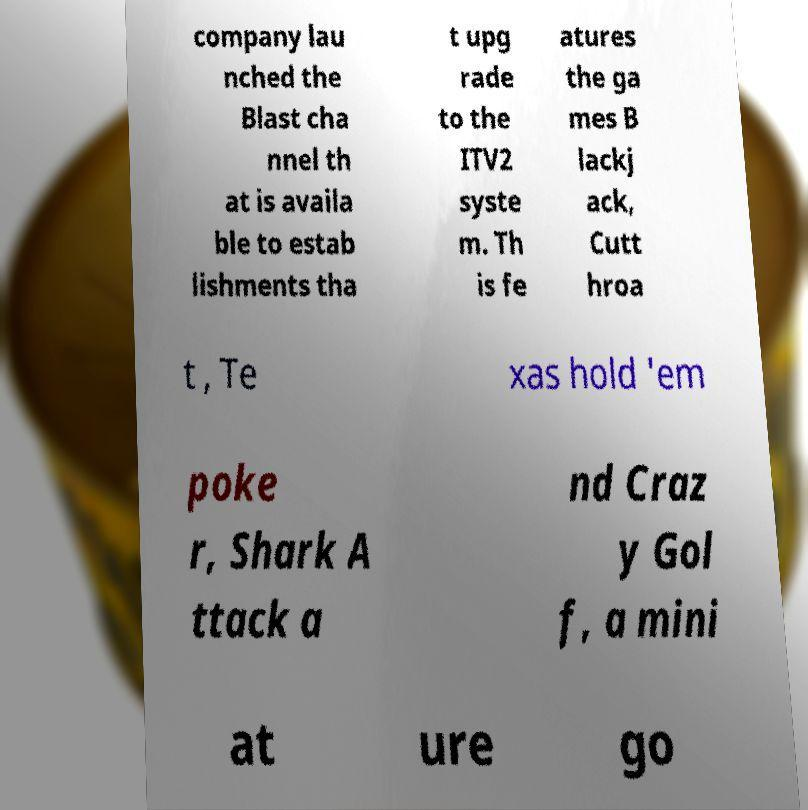Could you extract and type out the text from this image? company lau nched the Blast cha nnel th at is availa ble to estab lishments tha t upg rade to the ITV2 syste m. Th is fe atures the ga mes B lackj ack, Cutt hroa t , Te xas hold 'em poke r, Shark A ttack a nd Craz y Gol f, a mini at ure go 